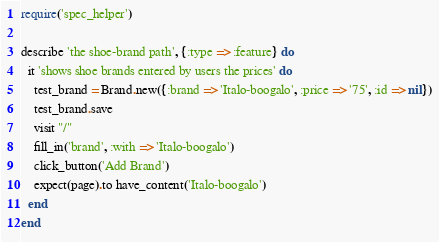Convert code to text. <code><loc_0><loc_0><loc_500><loc_500><_Ruby_>require('spec_helper')

describe 'the shoe-brand path', {:type => :feature} do
  it 'shows shoe brands entered by users the prices' do
    test_brand = Brand.new({:brand => 'Italo-boogalo', :price => '75', :id => nil})
    test_brand.save
    visit "/"
    fill_in('brand', :with => 'Italo-boogalo')
    click_button('Add Brand')
    expect(page).to have_content('Italo-boogalo')
  end
end
</code> 